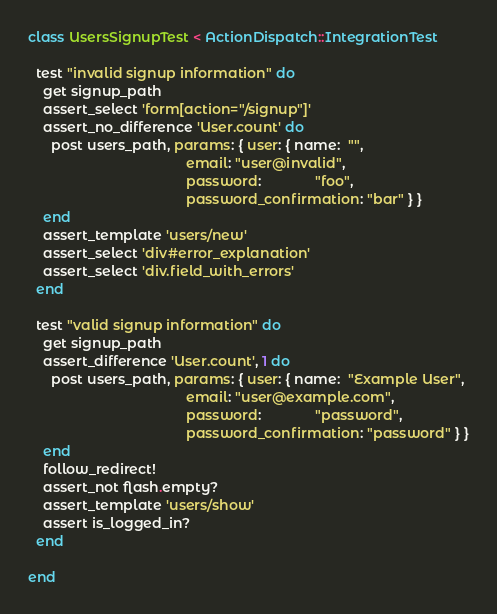Convert code to text. <code><loc_0><loc_0><loc_500><loc_500><_Ruby_>class UsersSignupTest < ActionDispatch::IntegrationTest

  test "invalid signup information" do
    get signup_path
    assert_select 'form[action="/signup"]'
    assert_no_difference 'User.count' do
      post users_path, params: { user: { name:  "",
                                         email: "user@invalid",
                                         password:              "foo",
                                         password_confirmation: "bar" } }
    end
    assert_template 'users/new'
    assert_select 'div#error_explanation'
    assert_select 'div.field_with_errors'
  end
  
  test "valid signup information" do
    get signup_path
    assert_difference 'User.count', 1 do
      post users_path, params: { user: { name:  "Example User",
                                         email: "user@example.com",
                                         password:              "password",
                                         password_confirmation: "password" } }
    end
    follow_redirect!
    assert_not flash.empty?    
    assert_template 'users/show'
    assert is_logged_in?
  end

end</code> 